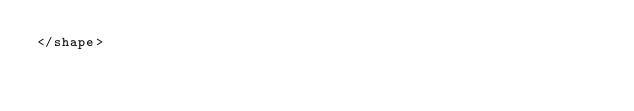Convert code to text. <code><loc_0><loc_0><loc_500><loc_500><_XML_></shape></code> 